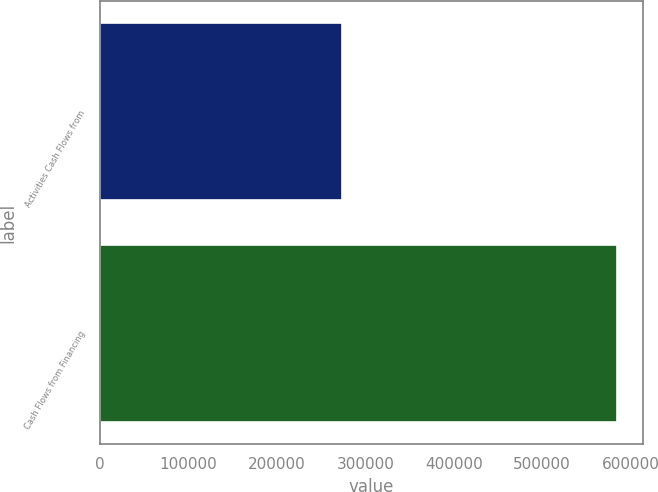<chart> <loc_0><loc_0><loc_500><loc_500><bar_chart><fcel>Activities Cash Flows from<fcel>Cash Flows from Financing<nl><fcel>274003<fcel>584507<nl></chart> 